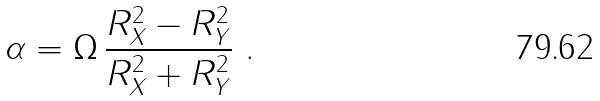Convert formula to latex. <formula><loc_0><loc_0><loc_500><loc_500>\alpha = \Omega \, \frac { R _ { X } ^ { 2 } - R _ { Y } ^ { 2 } } { R _ { X } ^ { 2 } + R _ { Y } ^ { 2 } } \ .</formula> 